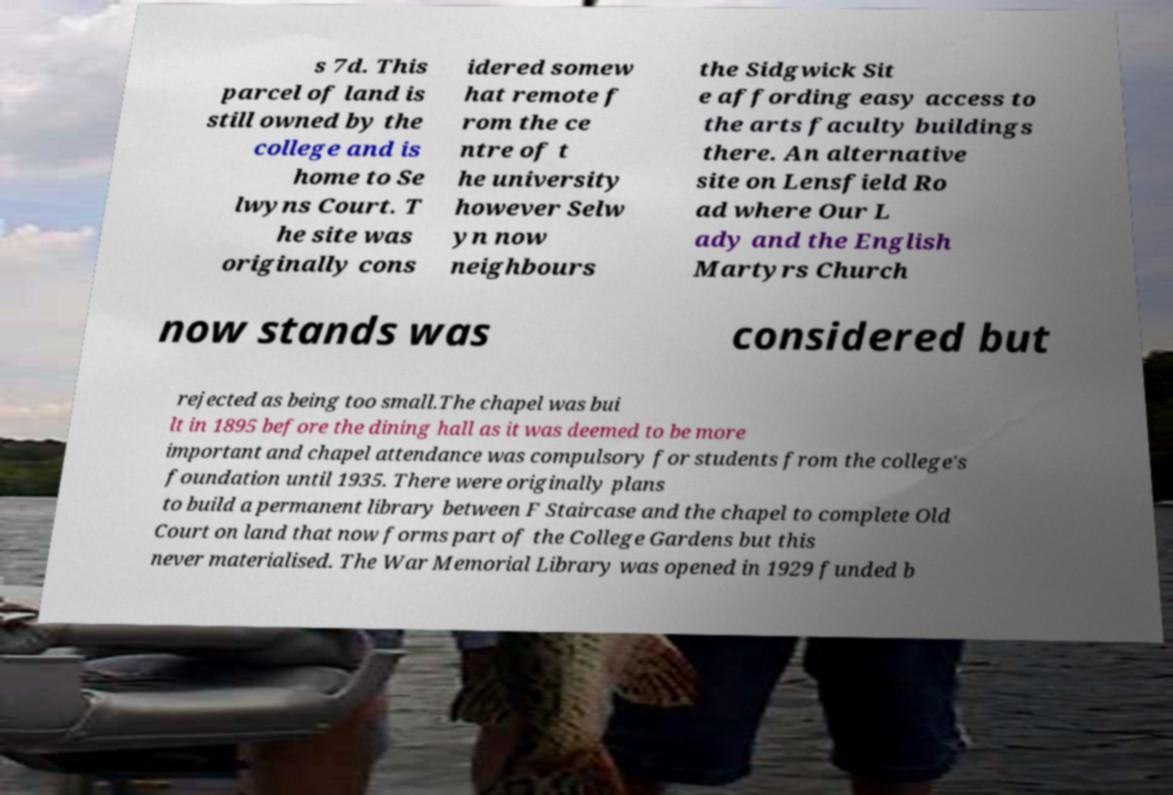I need the written content from this picture converted into text. Can you do that? s 7d. This parcel of land is still owned by the college and is home to Se lwyns Court. T he site was originally cons idered somew hat remote f rom the ce ntre of t he university however Selw yn now neighbours the Sidgwick Sit e affording easy access to the arts faculty buildings there. An alternative site on Lensfield Ro ad where Our L ady and the English Martyrs Church now stands was considered but rejected as being too small.The chapel was bui lt in 1895 before the dining hall as it was deemed to be more important and chapel attendance was compulsory for students from the college's foundation until 1935. There were originally plans to build a permanent library between F Staircase and the chapel to complete Old Court on land that now forms part of the College Gardens but this never materialised. The War Memorial Library was opened in 1929 funded b 